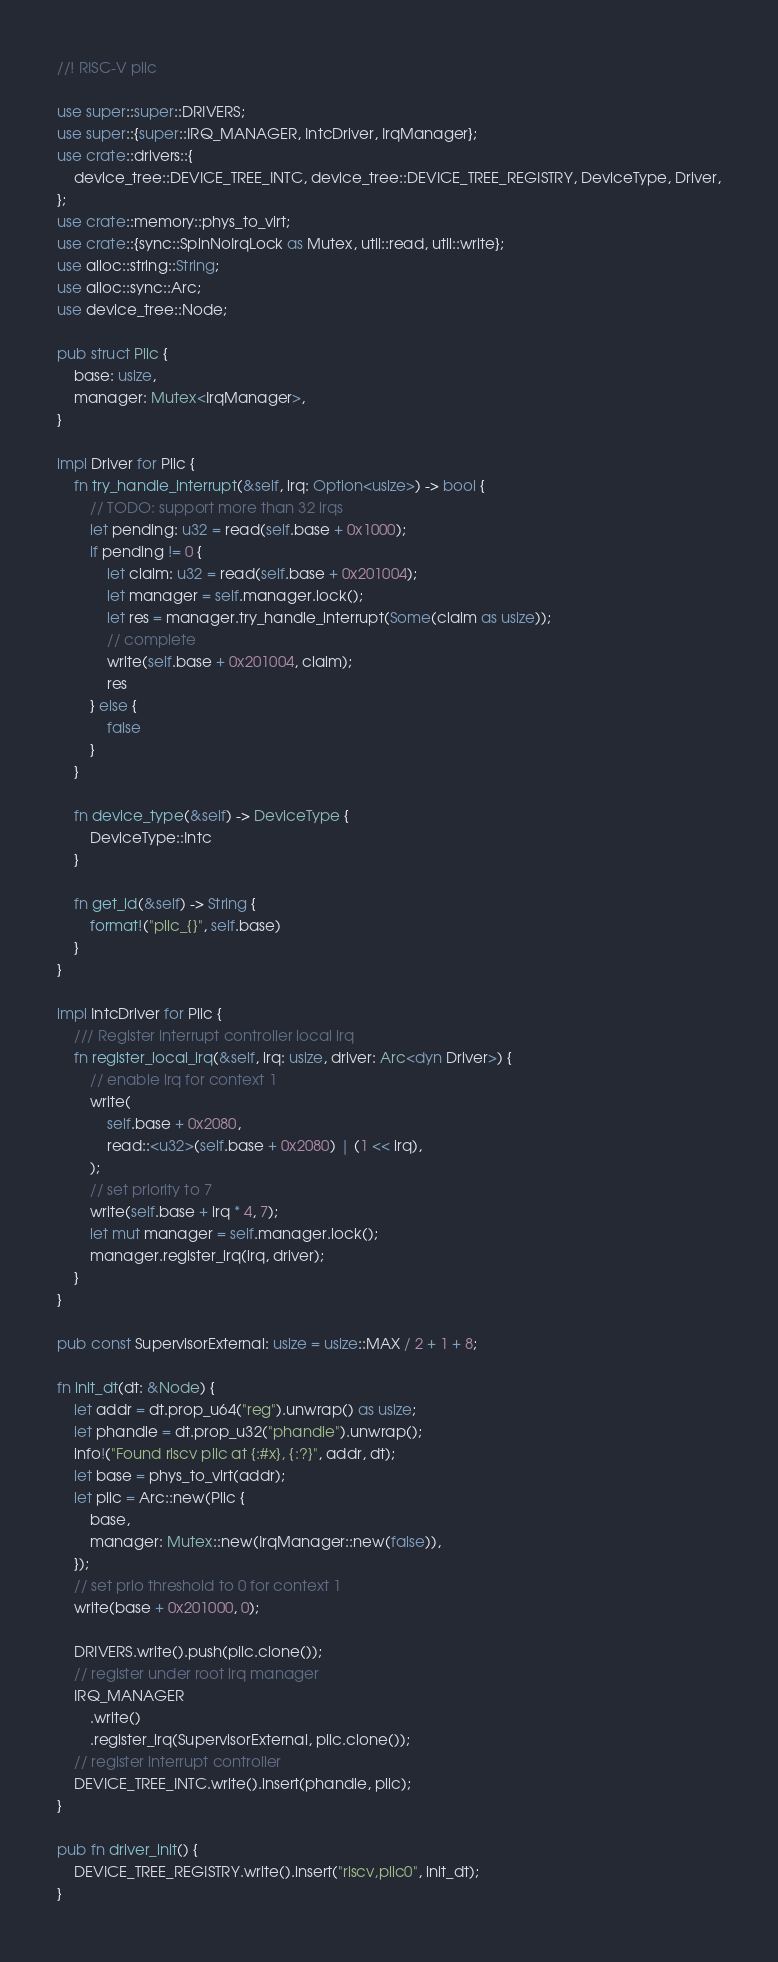<code> <loc_0><loc_0><loc_500><loc_500><_Rust_>//! RISC-V plic

use super::super::DRIVERS;
use super::{super::IRQ_MANAGER, IntcDriver, IrqManager};
use crate::drivers::{
    device_tree::DEVICE_TREE_INTC, device_tree::DEVICE_TREE_REGISTRY, DeviceType, Driver,
};
use crate::memory::phys_to_virt;
use crate::{sync::SpinNoIrqLock as Mutex, util::read, util::write};
use alloc::string::String;
use alloc::sync::Arc;
use device_tree::Node;

pub struct Plic {
    base: usize,
    manager: Mutex<IrqManager>,
}

impl Driver for Plic {
    fn try_handle_interrupt(&self, irq: Option<usize>) -> bool {
        // TODO: support more than 32 irqs
        let pending: u32 = read(self.base + 0x1000);
        if pending != 0 {
            let claim: u32 = read(self.base + 0x201004);
            let manager = self.manager.lock();
            let res = manager.try_handle_interrupt(Some(claim as usize));
            // complete
            write(self.base + 0x201004, claim);
            res
        } else {
            false
        }
    }

    fn device_type(&self) -> DeviceType {
        DeviceType::Intc
    }

    fn get_id(&self) -> String {
        format!("plic_{}", self.base)
    }
}

impl IntcDriver for Plic {
    /// Register interrupt controller local irq
    fn register_local_irq(&self, irq: usize, driver: Arc<dyn Driver>) {
        // enable irq for context 1
        write(
            self.base + 0x2080,
            read::<u32>(self.base + 0x2080) | (1 << irq),
        );
        // set priority to 7
        write(self.base + irq * 4, 7);
        let mut manager = self.manager.lock();
        manager.register_irq(irq, driver);
    }
}

pub const SupervisorExternal: usize = usize::MAX / 2 + 1 + 8;

fn init_dt(dt: &Node) {
    let addr = dt.prop_u64("reg").unwrap() as usize;
    let phandle = dt.prop_u32("phandle").unwrap();
    info!("Found riscv plic at {:#x}, {:?}", addr, dt);
    let base = phys_to_virt(addr);
    let plic = Arc::new(Plic {
        base,
        manager: Mutex::new(IrqManager::new(false)),
    });
    // set prio threshold to 0 for context 1
    write(base + 0x201000, 0);

    DRIVERS.write().push(plic.clone());
    // register under root irq manager
    IRQ_MANAGER
        .write()
        .register_irq(SupervisorExternal, plic.clone());
    // register interrupt controller
    DEVICE_TREE_INTC.write().insert(phandle, plic);
}

pub fn driver_init() {
    DEVICE_TREE_REGISTRY.write().insert("riscv,plic0", init_dt);
}
</code> 